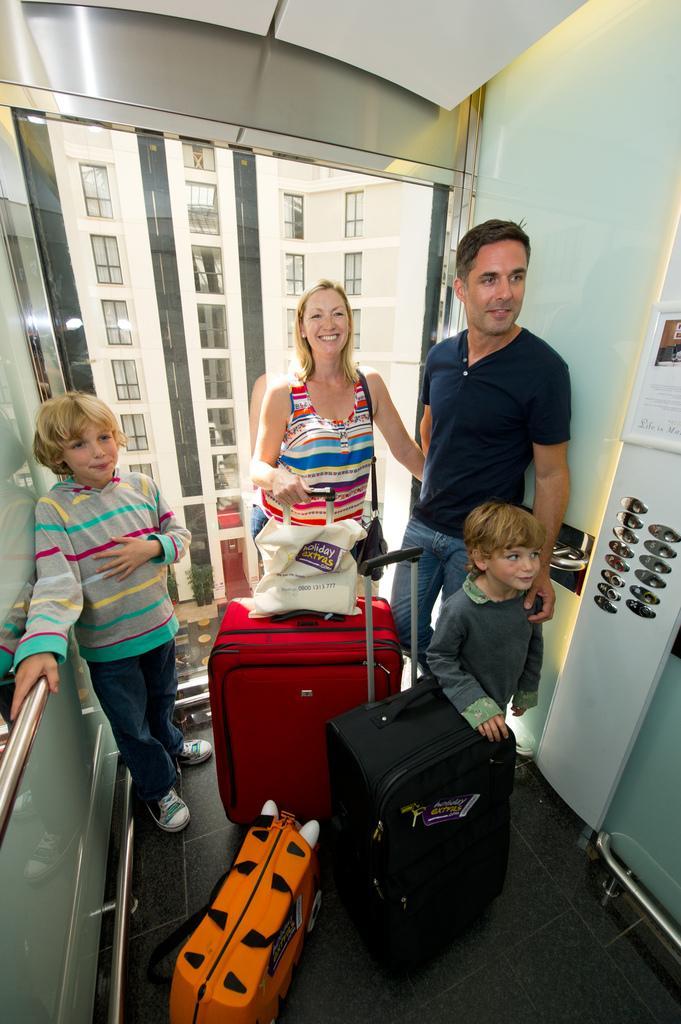Please provide a concise description of this image. This is the picture of some people with their luggage in the lift and behind them there is a glass wall and some silver buttons in the left. 